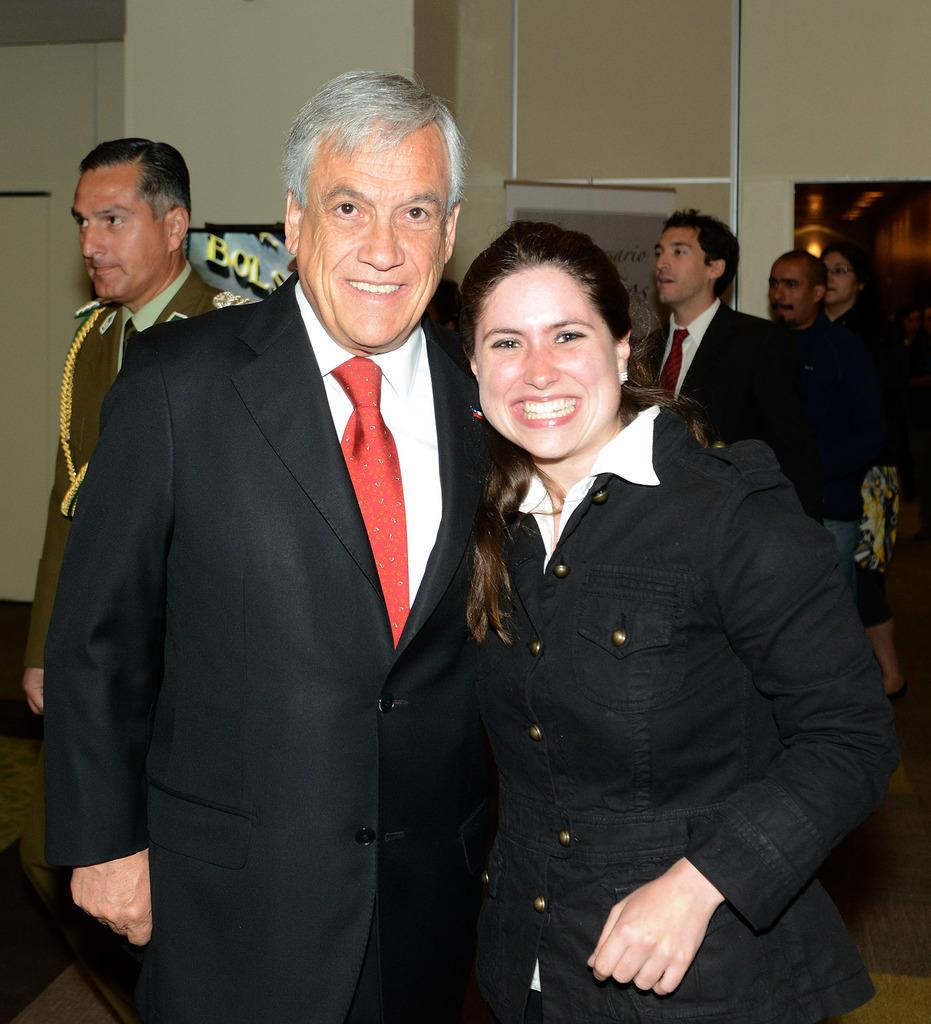How many people are in the image? There is a group of people standing in the image. What can be seen in the background of the image? There is a wall and a board with text in the background of the image. What type of root is growing out of the neck of the person in the image? There is no root or neck visible in the image; it features a group of people standing in front of a wall with a board. 